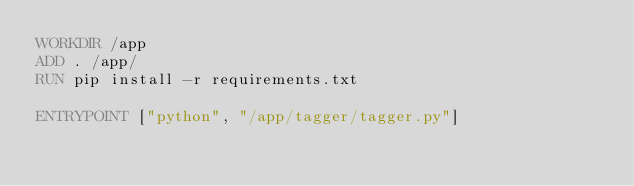<code> <loc_0><loc_0><loc_500><loc_500><_Dockerfile_>WORKDIR /app
ADD . /app/
RUN pip install -r requirements.txt

ENTRYPOINT ["python", "/app/tagger/tagger.py"]
</code> 